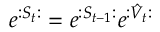<formula> <loc_0><loc_0><loc_500><loc_500>e ^ { \colon S _ { t } \colon } = e ^ { \colon S _ { t - 1 } \colon } e ^ { \colon \hat { V } _ { t } \colon }</formula> 